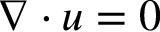Convert formula to latex. <formula><loc_0><loc_0><loc_500><loc_500>\nabla \cdot u = 0</formula> 